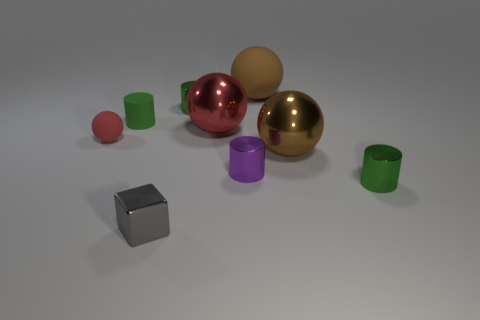Subtract all yellow blocks. How many green cylinders are left? 3 Subtract all blocks. How many objects are left? 8 Add 3 large red things. How many large red things exist? 4 Subtract 0 green cubes. How many objects are left? 9 Subtract all green cylinders. Subtract all cubes. How many objects are left? 5 Add 8 gray metal things. How many gray metal things are left? 9 